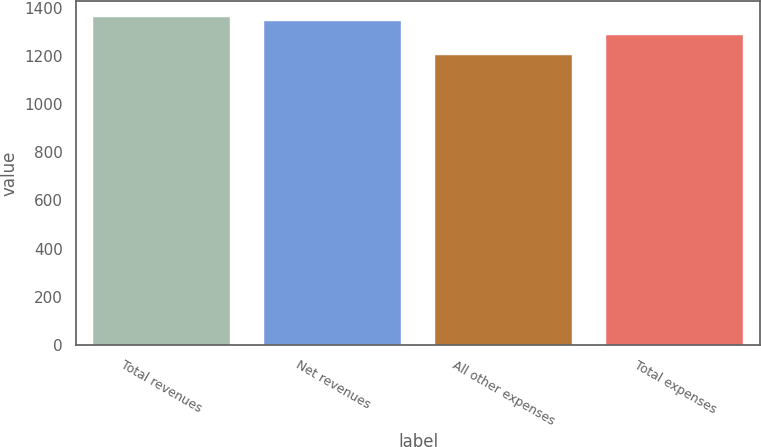Convert chart to OTSL. <chart><loc_0><loc_0><loc_500><loc_500><bar_chart><fcel>Total revenues<fcel>Net revenues<fcel>All other expenses<fcel>Total expenses<nl><fcel>1360.5<fcel>1346<fcel>1203<fcel>1286<nl></chart> 